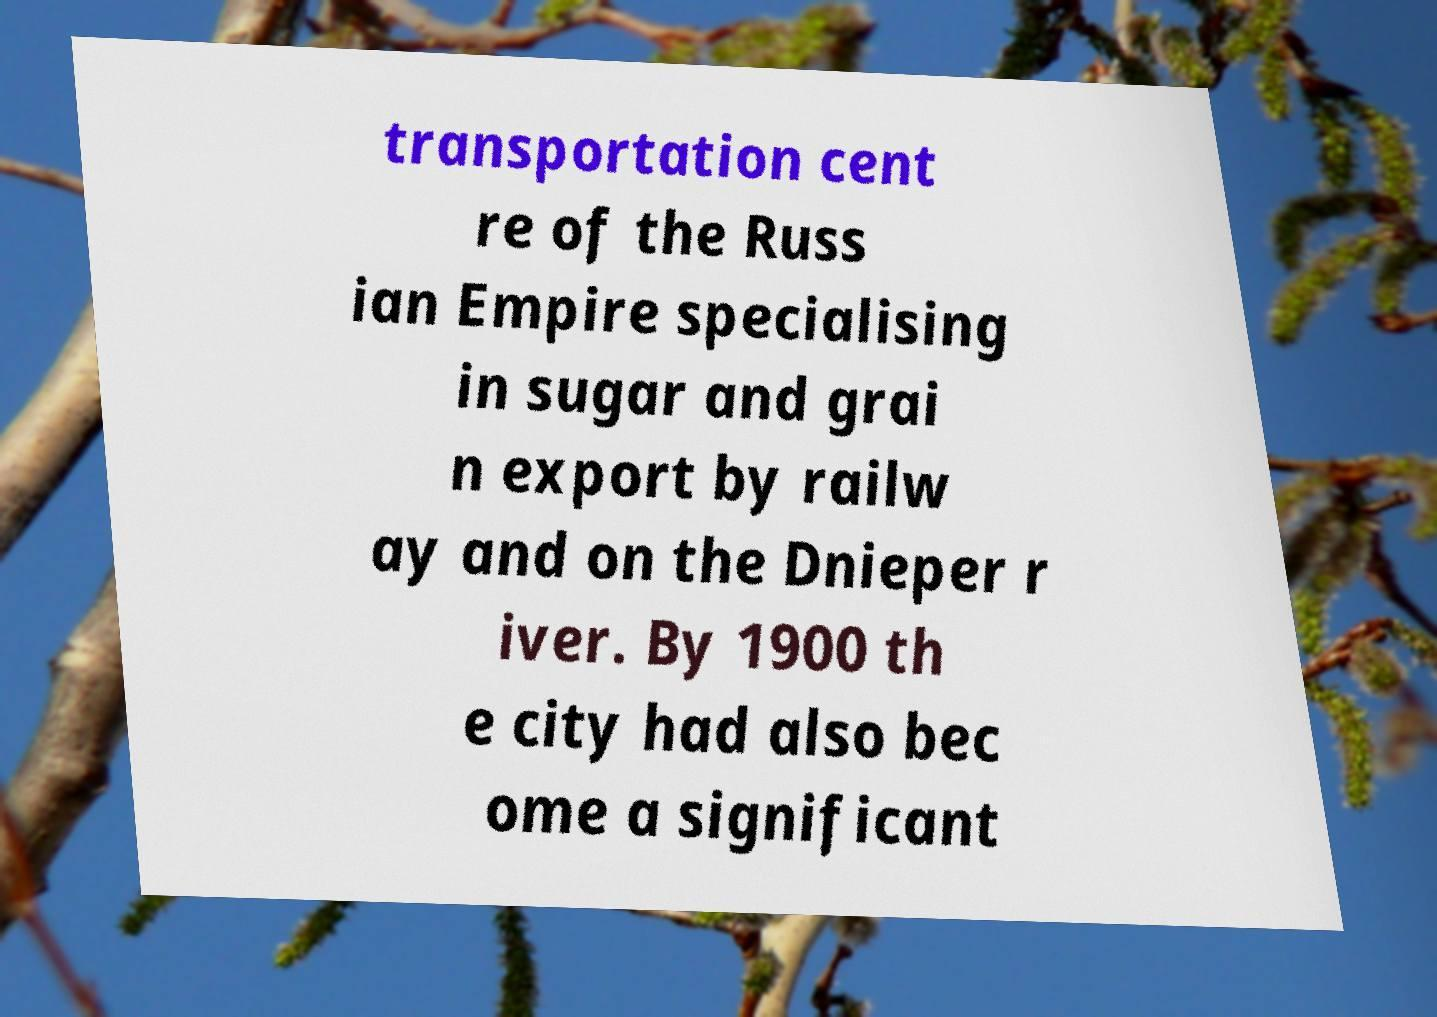There's text embedded in this image that I need extracted. Can you transcribe it verbatim? transportation cent re of the Russ ian Empire specialising in sugar and grai n export by railw ay and on the Dnieper r iver. By 1900 th e city had also bec ome a significant 